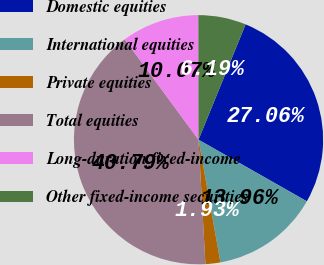<chart> <loc_0><loc_0><loc_500><loc_500><pie_chart><fcel>Domestic equities<fcel>International equities<fcel>Private equities<fcel>Total equities<fcel>Long-duration fixed-income<fcel>Other fixed-income securities<nl><fcel>27.06%<fcel>13.96%<fcel>1.93%<fcel>40.79%<fcel>10.07%<fcel>6.19%<nl></chart> 